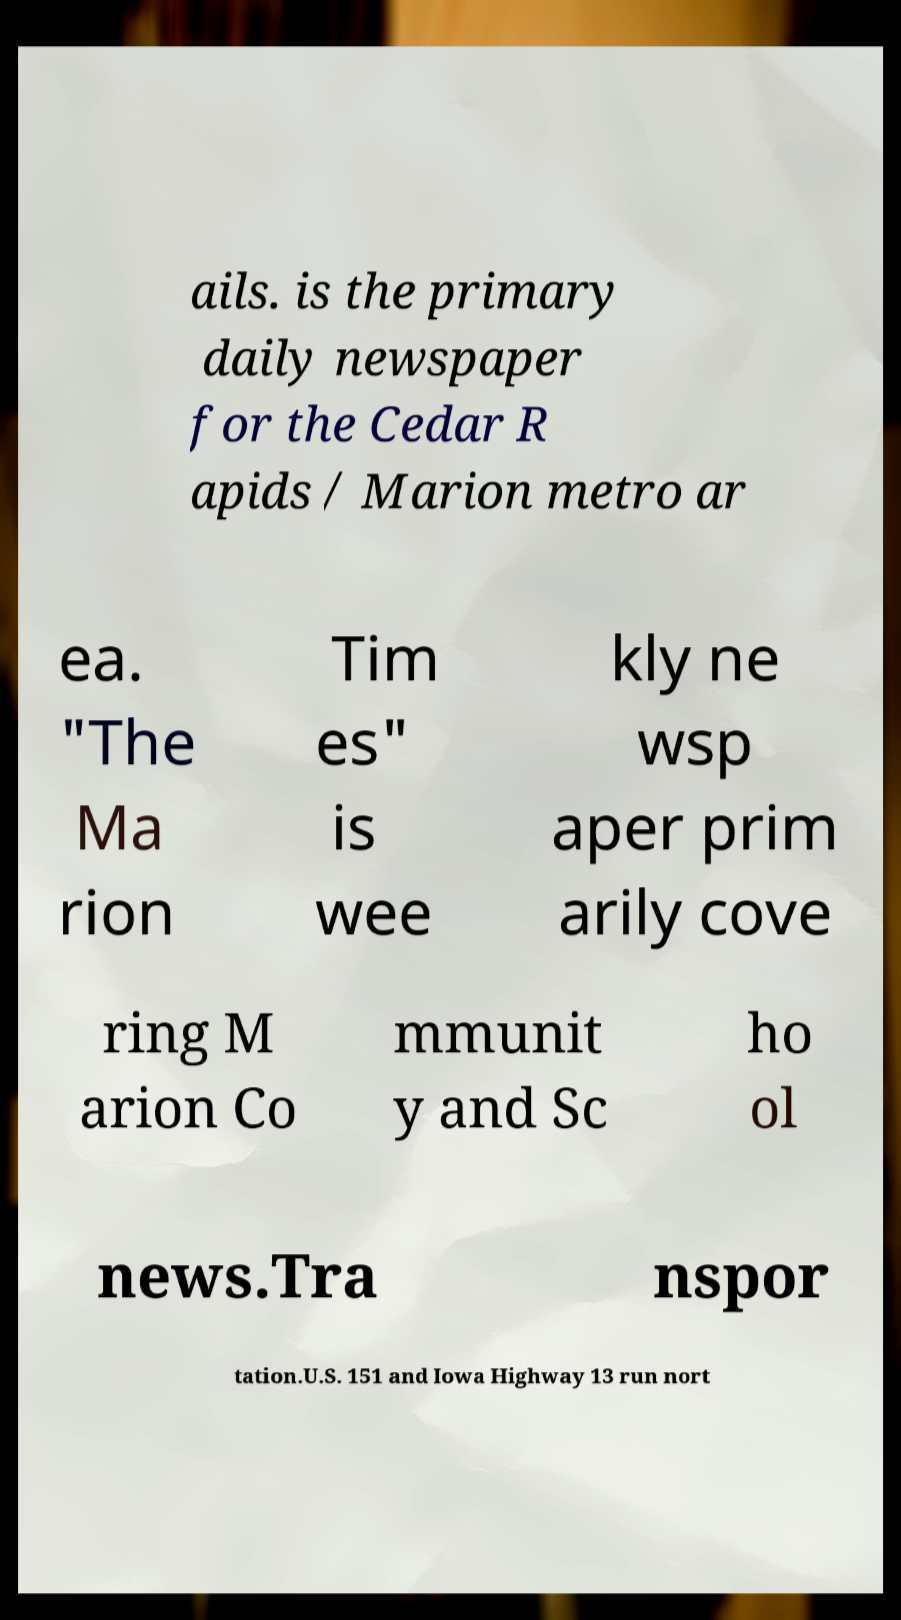There's text embedded in this image that I need extracted. Can you transcribe it verbatim? ails. is the primary daily newspaper for the Cedar R apids / Marion metro ar ea. "The Ma rion Tim es" is wee kly ne wsp aper prim arily cove ring M arion Co mmunit y and Sc ho ol news.Tra nspor tation.U.S. 151 and Iowa Highway 13 run nort 